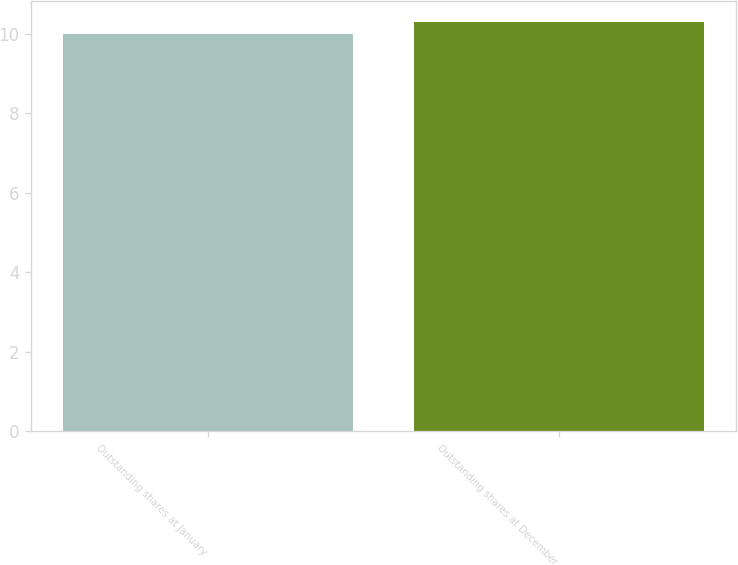Convert chart to OTSL. <chart><loc_0><loc_0><loc_500><loc_500><bar_chart><fcel>Outstanding shares at January<fcel>Outstanding shares at December<nl><fcel>10<fcel>10.3<nl></chart> 